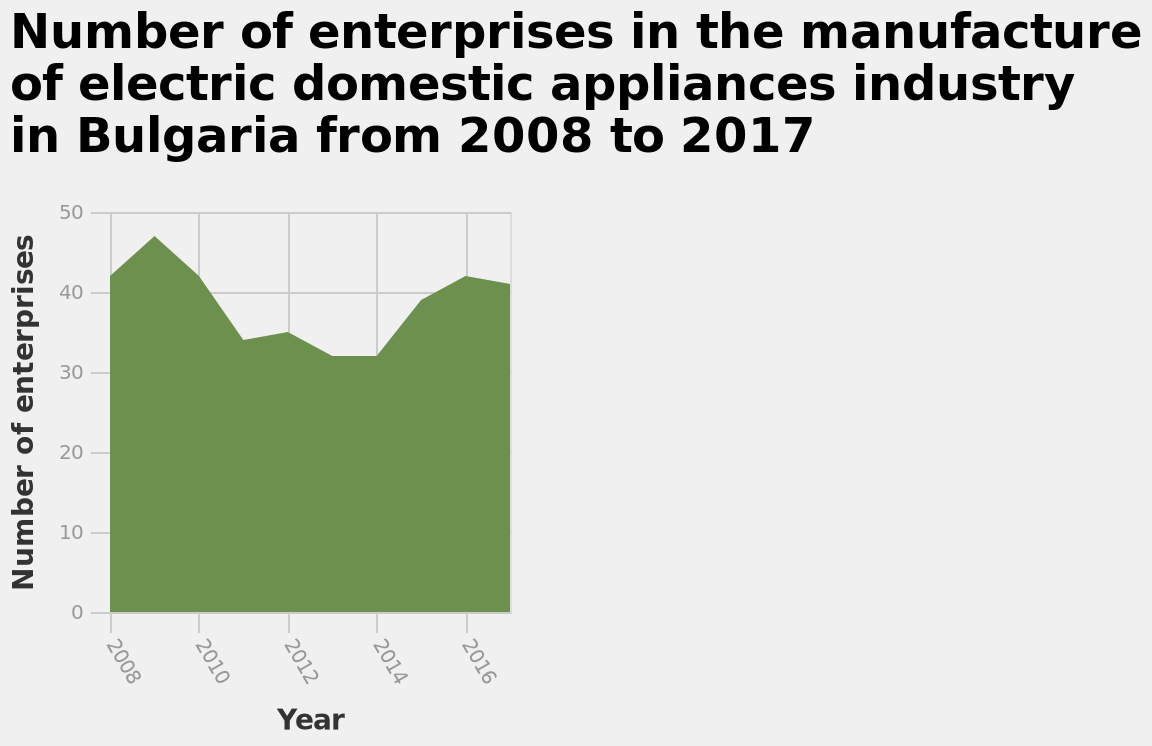<image>
What is the trend of the number of enterprises in the manufacture of electric domestic appliances industry in Bulgaria from 2008 to 2017?  Without the specific data from the plot, it is not possible to determine the exact trend of the number of enterprises. The plot would show whether the number of enterprises increased, decreased, or remained relatively stable over the years. 